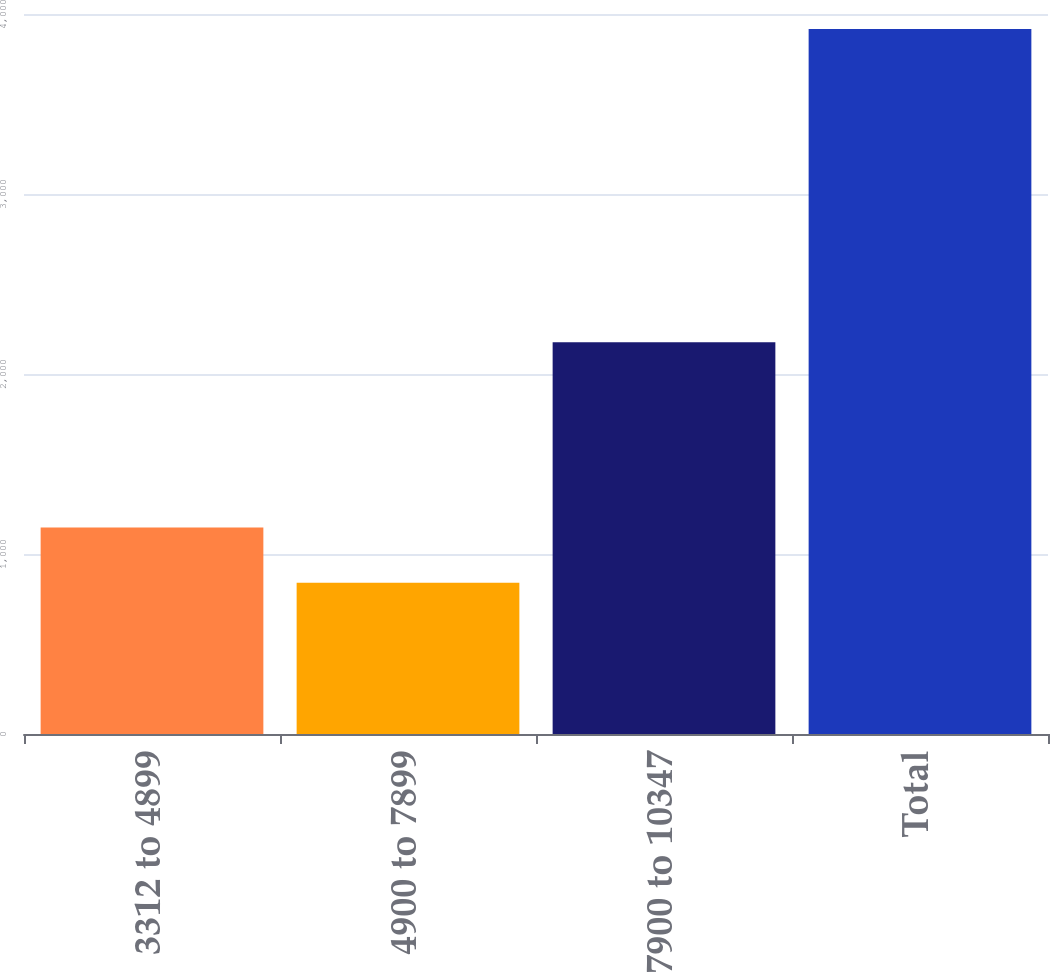Convert chart. <chart><loc_0><loc_0><loc_500><loc_500><bar_chart><fcel>3312 to 4899<fcel>4900 to 7899<fcel>7900 to 10347<fcel>Total<nl><fcel>1147.7<fcel>840<fcel>2176<fcel>3917<nl></chart> 